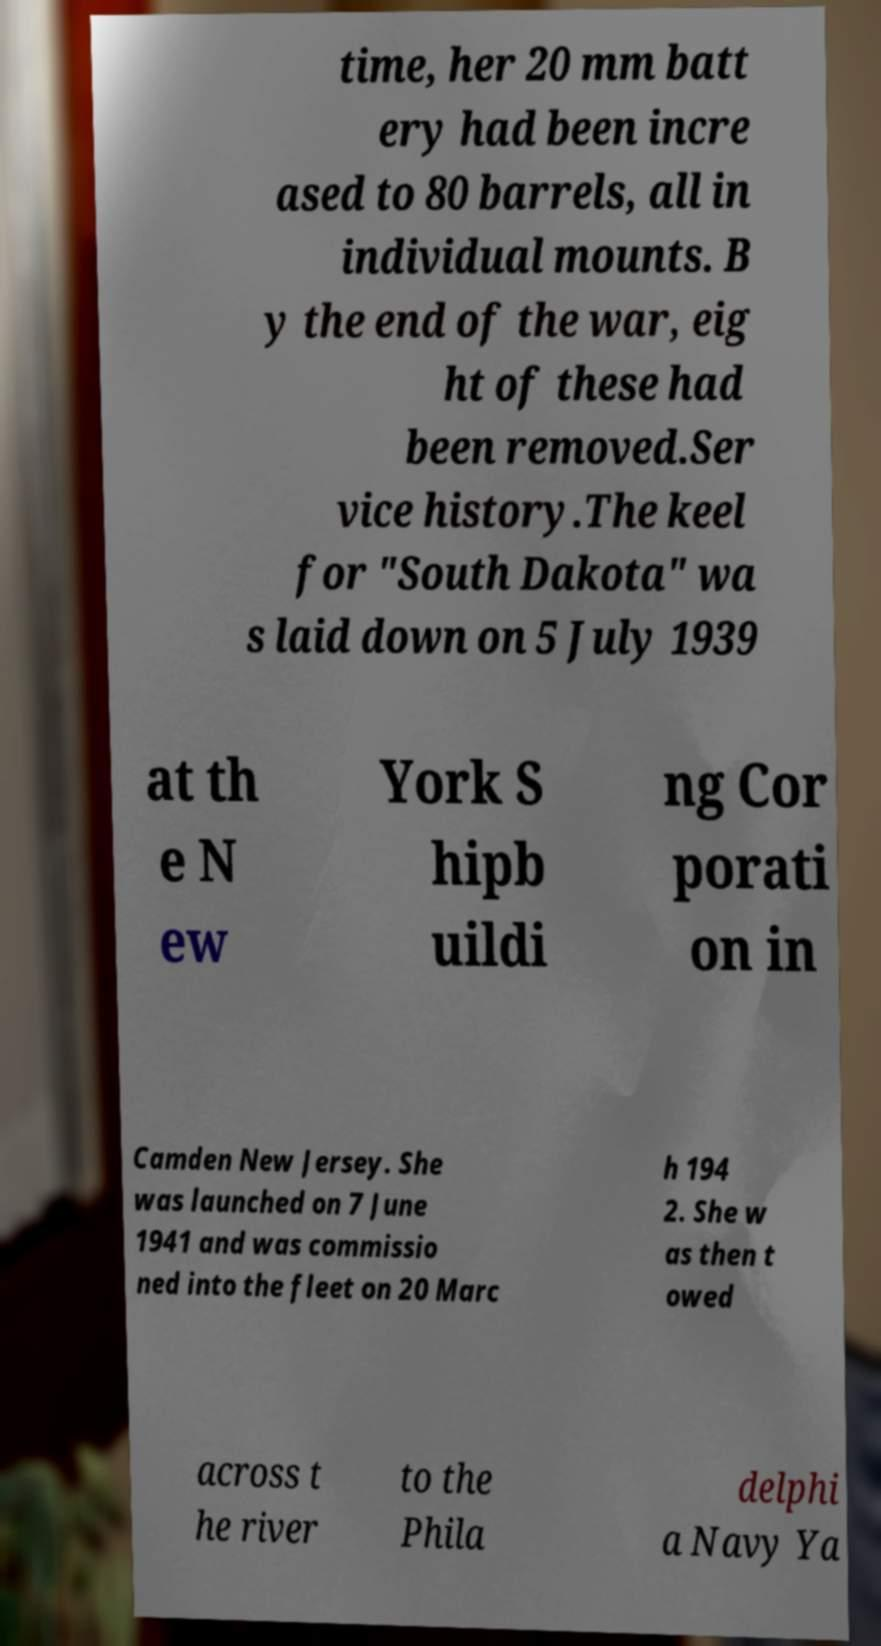For documentation purposes, I need the text within this image transcribed. Could you provide that? time, her 20 mm batt ery had been incre ased to 80 barrels, all in individual mounts. B y the end of the war, eig ht of these had been removed.Ser vice history.The keel for "South Dakota" wa s laid down on 5 July 1939 at th e N ew York S hipb uildi ng Cor porati on in Camden New Jersey. She was launched on 7 June 1941 and was commissio ned into the fleet on 20 Marc h 194 2. She w as then t owed across t he river to the Phila delphi a Navy Ya 